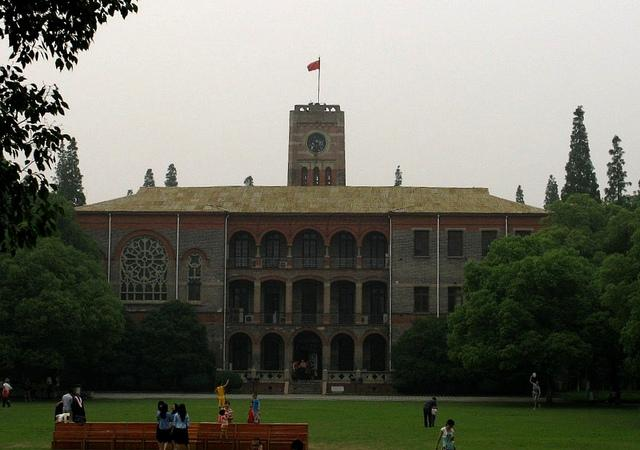What type of building is this most probably looking at the people in the courtyard?

Choices:
A) school
B) museum
C) housing
D) government office school 